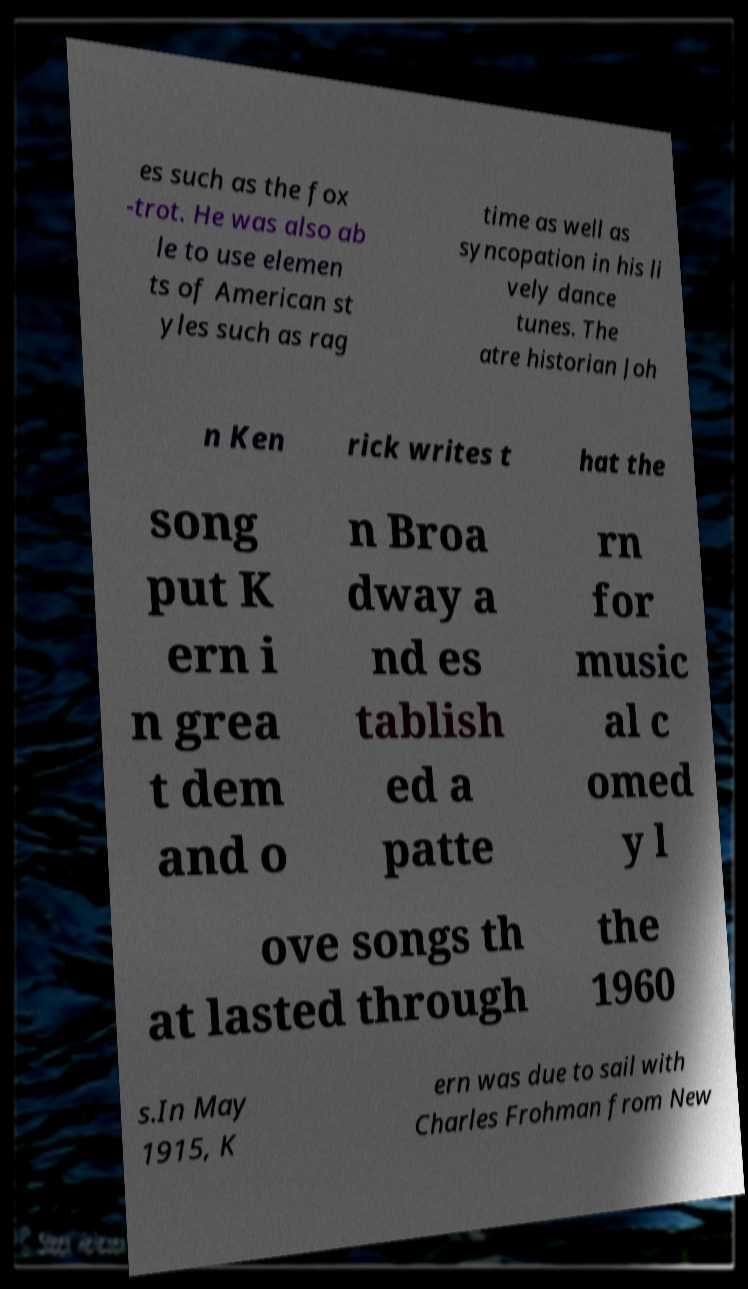For documentation purposes, I need the text within this image transcribed. Could you provide that? es such as the fox -trot. He was also ab le to use elemen ts of American st yles such as rag time as well as syncopation in his li vely dance tunes. The atre historian Joh n Ken rick writes t hat the song put K ern i n grea t dem and o n Broa dway a nd es tablish ed a patte rn for music al c omed y l ove songs th at lasted through the 1960 s.In May 1915, K ern was due to sail with Charles Frohman from New 